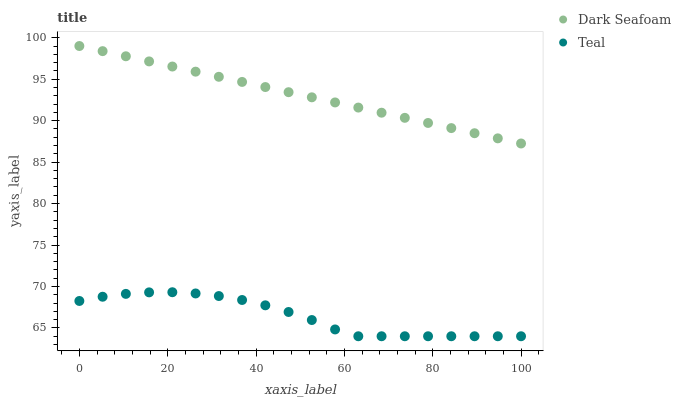Does Teal have the minimum area under the curve?
Answer yes or no. Yes. Does Dark Seafoam have the maximum area under the curve?
Answer yes or no. Yes. Does Teal have the maximum area under the curve?
Answer yes or no. No. Is Dark Seafoam the smoothest?
Answer yes or no. Yes. Is Teal the roughest?
Answer yes or no. Yes. Is Teal the smoothest?
Answer yes or no. No. Does Teal have the lowest value?
Answer yes or no. Yes. Does Dark Seafoam have the highest value?
Answer yes or no. Yes. Does Teal have the highest value?
Answer yes or no. No. Is Teal less than Dark Seafoam?
Answer yes or no. Yes. Is Dark Seafoam greater than Teal?
Answer yes or no. Yes. Does Teal intersect Dark Seafoam?
Answer yes or no. No. 